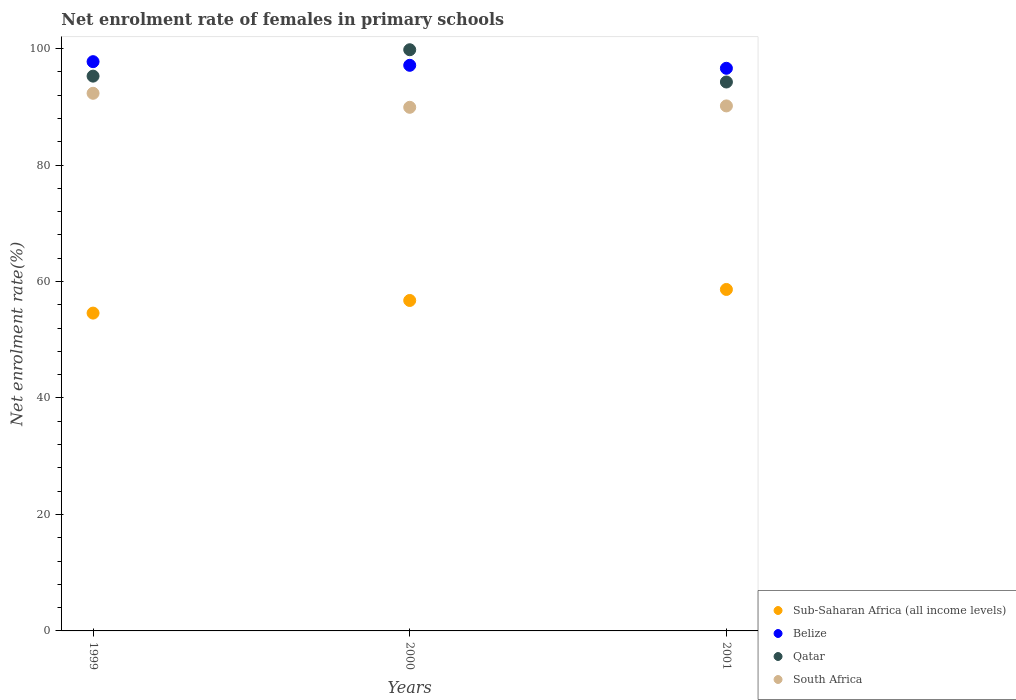What is the net enrolment rate of females in primary schools in Qatar in 2001?
Make the answer very short. 94.25. Across all years, what is the maximum net enrolment rate of females in primary schools in Qatar?
Keep it short and to the point. 99.79. Across all years, what is the minimum net enrolment rate of females in primary schools in Belize?
Offer a terse response. 96.61. In which year was the net enrolment rate of females in primary schools in Qatar maximum?
Your answer should be very brief. 2000. In which year was the net enrolment rate of females in primary schools in Sub-Saharan Africa (all income levels) minimum?
Give a very brief answer. 1999. What is the total net enrolment rate of females in primary schools in Sub-Saharan Africa (all income levels) in the graph?
Keep it short and to the point. 169.95. What is the difference between the net enrolment rate of females in primary schools in Belize in 2000 and that in 2001?
Keep it short and to the point. 0.51. What is the difference between the net enrolment rate of females in primary schools in Qatar in 2001 and the net enrolment rate of females in primary schools in Belize in 2000?
Make the answer very short. -2.87. What is the average net enrolment rate of females in primary schools in Belize per year?
Give a very brief answer. 97.16. In the year 2001, what is the difference between the net enrolment rate of females in primary schools in Belize and net enrolment rate of females in primary schools in Qatar?
Your answer should be very brief. 2.35. What is the ratio of the net enrolment rate of females in primary schools in South Africa in 1999 to that in 2001?
Provide a short and direct response. 1.02. Is the difference between the net enrolment rate of females in primary schools in Belize in 1999 and 2001 greater than the difference between the net enrolment rate of females in primary schools in Qatar in 1999 and 2001?
Keep it short and to the point. Yes. What is the difference between the highest and the second highest net enrolment rate of females in primary schools in Belize?
Give a very brief answer. 0.63. What is the difference between the highest and the lowest net enrolment rate of females in primary schools in Belize?
Keep it short and to the point. 1.14. Is it the case that in every year, the sum of the net enrolment rate of females in primary schools in Sub-Saharan Africa (all income levels) and net enrolment rate of females in primary schools in Belize  is greater than the sum of net enrolment rate of females in primary schools in Qatar and net enrolment rate of females in primary schools in South Africa?
Offer a very short reply. No. Is it the case that in every year, the sum of the net enrolment rate of females in primary schools in Belize and net enrolment rate of females in primary schools in Qatar  is greater than the net enrolment rate of females in primary schools in South Africa?
Ensure brevity in your answer.  Yes. Does the net enrolment rate of females in primary schools in Sub-Saharan Africa (all income levels) monotonically increase over the years?
Offer a terse response. Yes. Is the net enrolment rate of females in primary schools in Sub-Saharan Africa (all income levels) strictly less than the net enrolment rate of females in primary schools in South Africa over the years?
Your response must be concise. Yes. How many dotlines are there?
Your answer should be compact. 4. How many years are there in the graph?
Make the answer very short. 3. What is the difference between two consecutive major ticks on the Y-axis?
Provide a short and direct response. 20. Does the graph contain any zero values?
Keep it short and to the point. No. How are the legend labels stacked?
Make the answer very short. Vertical. What is the title of the graph?
Give a very brief answer. Net enrolment rate of females in primary schools. What is the label or title of the X-axis?
Your answer should be very brief. Years. What is the label or title of the Y-axis?
Provide a succinct answer. Net enrolment rate(%). What is the Net enrolment rate(%) of Sub-Saharan Africa (all income levels) in 1999?
Make the answer very short. 54.57. What is the Net enrolment rate(%) of Belize in 1999?
Offer a very short reply. 97.74. What is the Net enrolment rate(%) of Qatar in 1999?
Provide a short and direct response. 95.26. What is the Net enrolment rate(%) in South Africa in 1999?
Provide a short and direct response. 92.31. What is the Net enrolment rate(%) in Sub-Saharan Africa (all income levels) in 2000?
Give a very brief answer. 56.74. What is the Net enrolment rate(%) of Belize in 2000?
Your answer should be compact. 97.12. What is the Net enrolment rate(%) of Qatar in 2000?
Make the answer very short. 99.79. What is the Net enrolment rate(%) of South Africa in 2000?
Your answer should be very brief. 89.91. What is the Net enrolment rate(%) in Sub-Saharan Africa (all income levels) in 2001?
Keep it short and to the point. 58.63. What is the Net enrolment rate(%) of Belize in 2001?
Your response must be concise. 96.61. What is the Net enrolment rate(%) in Qatar in 2001?
Offer a terse response. 94.25. What is the Net enrolment rate(%) in South Africa in 2001?
Give a very brief answer. 90.15. Across all years, what is the maximum Net enrolment rate(%) of Sub-Saharan Africa (all income levels)?
Keep it short and to the point. 58.63. Across all years, what is the maximum Net enrolment rate(%) of Belize?
Offer a terse response. 97.74. Across all years, what is the maximum Net enrolment rate(%) of Qatar?
Offer a very short reply. 99.79. Across all years, what is the maximum Net enrolment rate(%) in South Africa?
Your answer should be compact. 92.31. Across all years, what is the minimum Net enrolment rate(%) in Sub-Saharan Africa (all income levels)?
Your answer should be compact. 54.57. Across all years, what is the minimum Net enrolment rate(%) of Belize?
Offer a very short reply. 96.61. Across all years, what is the minimum Net enrolment rate(%) of Qatar?
Offer a terse response. 94.25. Across all years, what is the minimum Net enrolment rate(%) of South Africa?
Offer a very short reply. 89.91. What is the total Net enrolment rate(%) in Sub-Saharan Africa (all income levels) in the graph?
Your response must be concise. 169.95. What is the total Net enrolment rate(%) of Belize in the graph?
Your answer should be compact. 291.47. What is the total Net enrolment rate(%) of Qatar in the graph?
Your response must be concise. 289.31. What is the total Net enrolment rate(%) in South Africa in the graph?
Make the answer very short. 272.37. What is the difference between the Net enrolment rate(%) of Sub-Saharan Africa (all income levels) in 1999 and that in 2000?
Keep it short and to the point. -2.17. What is the difference between the Net enrolment rate(%) of Belize in 1999 and that in 2000?
Offer a very short reply. 0.63. What is the difference between the Net enrolment rate(%) of Qatar in 1999 and that in 2000?
Offer a terse response. -4.53. What is the difference between the Net enrolment rate(%) of South Africa in 1999 and that in 2000?
Give a very brief answer. 2.41. What is the difference between the Net enrolment rate(%) of Sub-Saharan Africa (all income levels) in 1999 and that in 2001?
Your answer should be very brief. -4.06. What is the difference between the Net enrolment rate(%) in Belize in 1999 and that in 2001?
Give a very brief answer. 1.14. What is the difference between the Net enrolment rate(%) in Qatar in 1999 and that in 2001?
Offer a very short reply. 1.01. What is the difference between the Net enrolment rate(%) in South Africa in 1999 and that in 2001?
Offer a very short reply. 2.17. What is the difference between the Net enrolment rate(%) of Sub-Saharan Africa (all income levels) in 2000 and that in 2001?
Provide a short and direct response. -1.89. What is the difference between the Net enrolment rate(%) of Belize in 2000 and that in 2001?
Offer a terse response. 0.51. What is the difference between the Net enrolment rate(%) in Qatar in 2000 and that in 2001?
Ensure brevity in your answer.  5.54. What is the difference between the Net enrolment rate(%) in South Africa in 2000 and that in 2001?
Offer a very short reply. -0.24. What is the difference between the Net enrolment rate(%) in Sub-Saharan Africa (all income levels) in 1999 and the Net enrolment rate(%) in Belize in 2000?
Keep it short and to the point. -42.55. What is the difference between the Net enrolment rate(%) of Sub-Saharan Africa (all income levels) in 1999 and the Net enrolment rate(%) of Qatar in 2000?
Give a very brief answer. -45.22. What is the difference between the Net enrolment rate(%) in Sub-Saharan Africa (all income levels) in 1999 and the Net enrolment rate(%) in South Africa in 2000?
Provide a succinct answer. -35.33. What is the difference between the Net enrolment rate(%) in Belize in 1999 and the Net enrolment rate(%) in Qatar in 2000?
Offer a very short reply. -2.05. What is the difference between the Net enrolment rate(%) in Belize in 1999 and the Net enrolment rate(%) in South Africa in 2000?
Offer a terse response. 7.84. What is the difference between the Net enrolment rate(%) in Qatar in 1999 and the Net enrolment rate(%) in South Africa in 2000?
Offer a terse response. 5.35. What is the difference between the Net enrolment rate(%) of Sub-Saharan Africa (all income levels) in 1999 and the Net enrolment rate(%) of Belize in 2001?
Your answer should be compact. -42.03. What is the difference between the Net enrolment rate(%) of Sub-Saharan Africa (all income levels) in 1999 and the Net enrolment rate(%) of Qatar in 2001?
Offer a terse response. -39.68. What is the difference between the Net enrolment rate(%) of Sub-Saharan Africa (all income levels) in 1999 and the Net enrolment rate(%) of South Africa in 2001?
Provide a succinct answer. -35.58. What is the difference between the Net enrolment rate(%) in Belize in 1999 and the Net enrolment rate(%) in Qatar in 2001?
Give a very brief answer. 3.49. What is the difference between the Net enrolment rate(%) of Belize in 1999 and the Net enrolment rate(%) of South Africa in 2001?
Ensure brevity in your answer.  7.6. What is the difference between the Net enrolment rate(%) in Qatar in 1999 and the Net enrolment rate(%) in South Africa in 2001?
Your answer should be compact. 5.11. What is the difference between the Net enrolment rate(%) in Sub-Saharan Africa (all income levels) in 2000 and the Net enrolment rate(%) in Belize in 2001?
Your response must be concise. -39.87. What is the difference between the Net enrolment rate(%) of Sub-Saharan Africa (all income levels) in 2000 and the Net enrolment rate(%) of Qatar in 2001?
Provide a short and direct response. -37.51. What is the difference between the Net enrolment rate(%) of Sub-Saharan Africa (all income levels) in 2000 and the Net enrolment rate(%) of South Africa in 2001?
Your answer should be compact. -33.41. What is the difference between the Net enrolment rate(%) in Belize in 2000 and the Net enrolment rate(%) in Qatar in 2001?
Offer a terse response. 2.87. What is the difference between the Net enrolment rate(%) in Belize in 2000 and the Net enrolment rate(%) in South Africa in 2001?
Keep it short and to the point. 6.97. What is the difference between the Net enrolment rate(%) of Qatar in 2000 and the Net enrolment rate(%) of South Africa in 2001?
Your response must be concise. 9.64. What is the average Net enrolment rate(%) in Sub-Saharan Africa (all income levels) per year?
Offer a very short reply. 56.65. What is the average Net enrolment rate(%) of Belize per year?
Offer a very short reply. 97.16. What is the average Net enrolment rate(%) of Qatar per year?
Make the answer very short. 96.44. What is the average Net enrolment rate(%) of South Africa per year?
Provide a short and direct response. 90.79. In the year 1999, what is the difference between the Net enrolment rate(%) in Sub-Saharan Africa (all income levels) and Net enrolment rate(%) in Belize?
Make the answer very short. -43.17. In the year 1999, what is the difference between the Net enrolment rate(%) of Sub-Saharan Africa (all income levels) and Net enrolment rate(%) of Qatar?
Your answer should be very brief. -40.69. In the year 1999, what is the difference between the Net enrolment rate(%) of Sub-Saharan Africa (all income levels) and Net enrolment rate(%) of South Africa?
Provide a short and direct response. -37.74. In the year 1999, what is the difference between the Net enrolment rate(%) in Belize and Net enrolment rate(%) in Qatar?
Offer a very short reply. 2.48. In the year 1999, what is the difference between the Net enrolment rate(%) of Belize and Net enrolment rate(%) of South Africa?
Offer a terse response. 5.43. In the year 1999, what is the difference between the Net enrolment rate(%) of Qatar and Net enrolment rate(%) of South Africa?
Make the answer very short. 2.95. In the year 2000, what is the difference between the Net enrolment rate(%) in Sub-Saharan Africa (all income levels) and Net enrolment rate(%) in Belize?
Make the answer very short. -40.38. In the year 2000, what is the difference between the Net enrolment rate(%) in Sub-Saharan Africa (all income levels) and Net enrolment rate(%) in Qatar?
Keep it short and to the point. -43.05. In the year 2000, what is the difference between the Net enrolment rate(%) in Sub-Saharan Africa (all income levels) and Net enrolment rate(%) in South Africa?
Give a very brief answer. -33.17. In the year 2000, what is the difference between the Net enrolment rate(%) in Belize and Net enrolment rate(%) in Qatar?
Offer a very short reply. -2.67. In the year 2000, what is the difference between the Net enrolment rate(%) in Belize and Net enrolment rate(%) in South Africa?
Provide a succinct answer. 7.21. In the year 2000, what is the difference between the Net enrolment rate(%) in Qatar and Net enrolment rate(%) in South Africa?
Your answer should be very brief. 9.88. In the year 2001, what is the difference between the Net enrolment rate(%) of Sub-Saharan Africa (all income levels) and Net enrolment rate(%) of Belize?
Your answer should be compact. -37.98. In the year 2001, what is the difference between the Net enrolment rate(%) of Sub-Saharan Africa (all income levels) and Net enrolment rate(%) of Qatar?
Your response must be concise. -35.62. In the year 2001, what is the difference between the Net enrolment rate(%) in Sub-Saharan Africa (all income levels) and Net enrolment rate(%) in South Africa?
Your answer should be compact. -31.52. In the year 2001, what is the difference between the Net enrolment rate(%) of Belize and Net enrolment rate(%) of Qatar?
Make the answer very short. 2.35. In the year 2001, what is the difference between the Net enrolment rate(%) in Belize and Net enrolment rate(%) in South Africa?
Provide a succinct answer. 6.46. In the year 2001, what is the difference between the Net enrolment rate(%) in Qatar and Net enrolment rate(%) in South Africa?
Your answer should be very brief. 4.1. What is the ratio of the Net enrolment rate(%) in Sub-Saharan Africa (all income levels) in 1999 to that in 2000?
Make the answer very short. 0.96. What is the ratio of the Net enrolment rate(%) of Belize in 1999 to that in 2000?
Your response must be concise. 1.01. What is the ratio of the Net enrolment rate(%) of Qatar in 1999 to that in 2000?
Keep it short and to the point. 0.95. What is the ratio of the Net enrolment rate(%) in South Africa in 1999 to that in 2000?
Provide a short and direct response. 1.03. What is the ratio of the Net enrolment rate(%) of Sub-Saharan Africa (all income levels) in 1999 to that in 2001?
Offer a very short reply. 0.93. What is the ratio of the Net enrolment rate(%) of Belize in 1999 to that in 2001?
Ensure brevity in your answer.  1.01. What is the ratio of the Net enrolment rate(%) in Qatar in 1999 to that in 2001?
Keep it short and to the point. 1.01. What is the ratio of the Net enrolment rate(%) in Belize in 2000 to that in 2001?
Give a very brief answer. 1.01. What is the ratio of the Net enrolment rate(%) of Qatar in 2000 to that in 2001?
Provide a succinct answer. 1.06. What is the difference between the highest and the second highest Net enrolment rate(%) of Sub-Saharan Africa (all income levels)?
Provide a short and direct response. 1.89. What is the difference between the highest and the second highest Net enrolment rate(%) of Belize?
Your response must be concise. 0.63. What is the difference between the highest and the second highest Net enrolment rate(%) of Qatar?
Offer a very short reply. 4.53. What is the difference between the highest and the second highest Net enrolment rate(%) in South Africa?
Offer a very short reply. 2.17. What is the difference between the highest and the lowest Net enrolment rate(%) in Sub-Saharan Africa (all income levels)?
Offer a terse response. 4.06. What is the difference between the highest and the lowest Net enrolment rate(%) in Belize?
Offer a terse response. 1.14. What is the difference between the highest and the lowest Net enrolment rate(%) of Qatar?
Provide a short and direct response. 5.54. What is the difference between the highest and the lowest Net enrolment rate(%) in South Africa?
Your answer should be very brief. 2.41. 